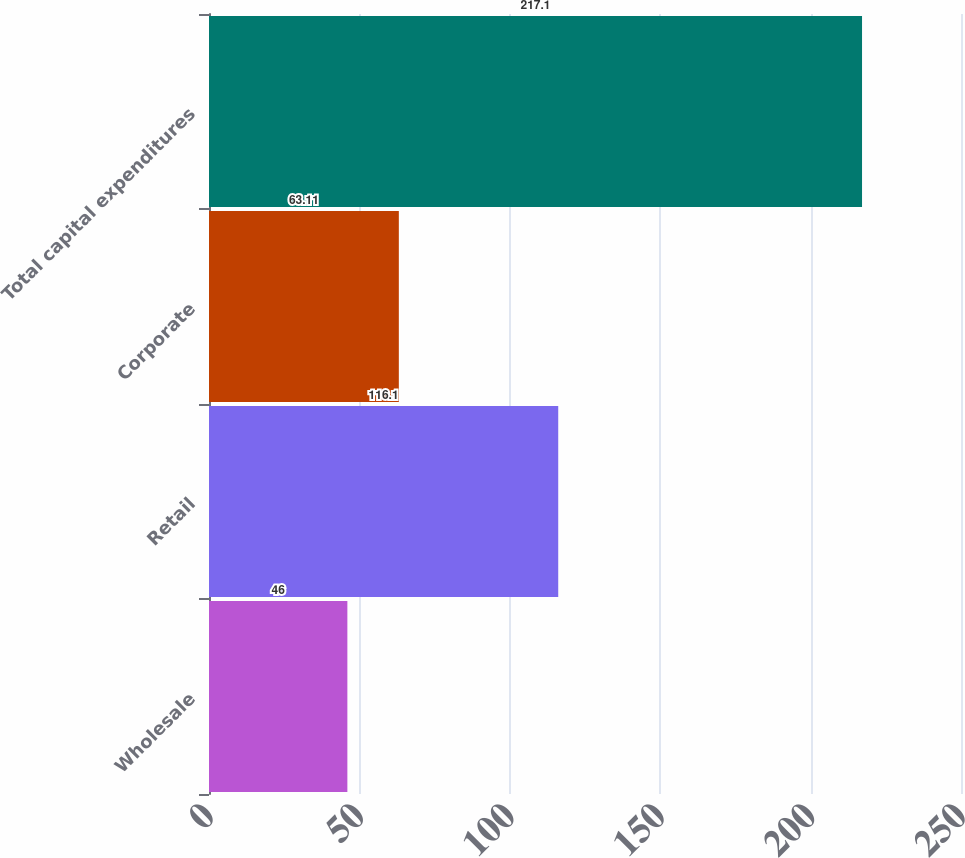Convert chart. <chart><loc_0><loc_0><loc_500><loc_500><bar_chart><fcel>Wholesale<fcel>Retail<fcel>Corporate<fcel>Total capital expenditures<nl><fcel>46<fcel>116.1<fcel>63.11<fcel>217.1<nl></chart> 